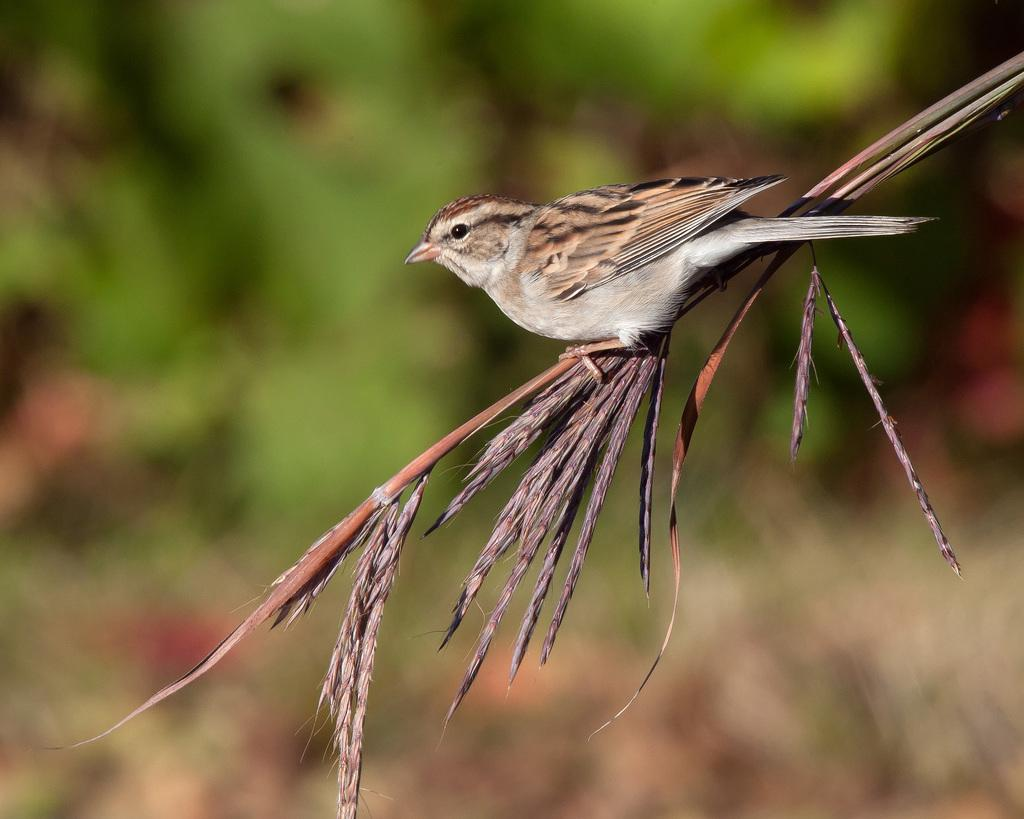What type of animal can be seen in the image? There is a bird in the image. Where is the bird located? The bird is on a stem of a plant. How many oranges are hanging from the bird's beak in the image? There are no oranges present in the image, and the bird's beak is not visible. 